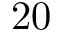<formula> <loc_0><loc_0><loc_500><loc_500>2 0</formula> 